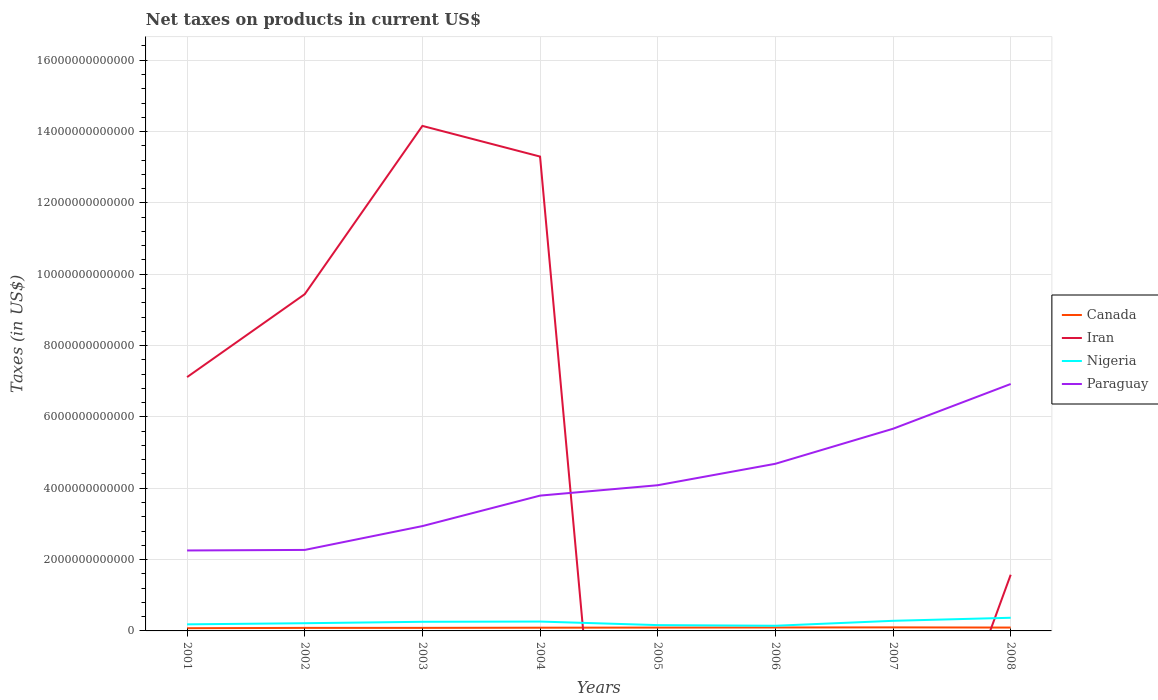How many different coloured lines are there?
Your response must be concise. 4. Is the number of lines equal to the number of legend labels?
Make the answer very short. No. Across all years, what is the maximum net taxes on products in Iran?
Offer a very short reply. 0. What is the total net taxes on products in Paraguay in the graph?
Your answer should be very brief. -6.01e+11. What is the difference between the highest and the second highest net taxes on products in Nigeria?
Provide a succinct answer. 2.24e+11. Is the net taxes on products in Paraguay strictly greater than the net taxes on products in Nigeria over the years?
Your answer should be compact. No. How many years are there in the graph?
Your answer should be compact. 8. What is the difference between two consecutive major ticks on the Y-axis?
Offer a terse response. 2.00e+12. Does the graph contain any zero values?
Provide a short and direct response. Yes. How are the legend labels stacked?
Give a very brief answer. Vertical. What is the title of the graph?
Provide a succinct answer. Net taxes on products in current US$. What is the label or title of the Y-axis?
Ensure brevity in your answer.  Taxes (in US$). What is the Taxes (in US$) in Canada in 2001?
Give a very brief answer. 7.62e+1. What is the Taxes (in US$) in Iran in 2001?
Make the answer very short. 7.12e+12. What is the Taxes (in US$) in Nigeria in 2001?
Give a very brief answer. 1.84e+11. What is the Taxes (in US$) in Paraguay in 2001?
Provide a short and direct response. 2.26e+12. What is the Taxes (in US$) in Canada in 2002?
Keep it short and to the point. 8.48e+1. What is the Taxes (in US$) of Iran in 2002?
Make the answer very short. 9.44e+12. What is the Taxes (in US$) of Nigeria in 2002?
Keep it short and to the point. 2.16e+11. What is the Taxes (in US$) in Paraguay in 2002?
Ensure brevity in your answer.  2.27e+12. What is the Taxes (in US$) in Canada in 2003?
Your answer should be very brief. 8.53e+1. What is the Taxes (in US$) in Iran in 2003?
Your response must be concise. 1.42e+13. What is the Taxes (in US$) of Nigeria in 2003?
Make the answer very short. 2.56e+11. What is the Taxes (in US$) in Paraguay in 2003?
Offer a terse response. 2.94e+12. What is the Taxes (in US$) in Canada in 2004?
Your response must be concise. 9.02e+1. What is the Taxes (in US$) of Iran in 2004?
Provide a succinct answer. 1.33e+13. What is the Taxes (in US$) of Nigeria in 2004?
Provide a succinct answer. 2.63e+11. What is the Taxes (in US$) of Paraguay in 2004?
Offer a terse response. 3.79e+12. What is the Taxes (in US$) in Canada in 2005?
Provide a succinct answer. 9.38e+1. What is the Taxes (in US$) in Nigeria in 2005?
Provide a short and direct response. 1.63e+11. What is the Taxes (in US$) in Paraguay in 2005?
Your answer should be compact. 4.08e+12. What is the Taxes (in US$) of Canada in 2006?
Your response must be concise. 9.66e+1. What is the Taxes (in US$) of Iran in 2006?
Keep it short and to the point. 0. What is the Taxes (in US$) of Nigeria in 2006?
Keep it short and to the point. 1.45e+11. What is the Taxes (in US$) in Paraguay in 2006?
Your response must be concise. 4.69e+12. What is the Taxes (in US$) in Canada in 2007?
Ensure brevity in your answer.  9.92e+1. What is the Taxes (in US$) of Nigeria in 2007?
Your answer should be compact. 2.84e+11. What is the Taxes (in US$) of Paraguay in 2007?
Provide a short and direct response. 5.67e+12. What is the Taxes (in US$) in Canada in 2008?
Provide a short and direct response. 9.43e+1. What is the Taxes (in US$) in Iran in 2008?
Make the answer very short. 1.58e+12. What is the Taxes (in US$) of Nigeria in 2008?
Ensure brevity in your answer.  3.69e+11. What is the Taxes (in US$) of Paraguay in 2008?
Your answer should be very brief. 6.92e+12. Across all years, what is the maximum Taxes (in US$) in Canada?
Your answer should be compact. 9.92e+1. Across all years, what is the maximum Taxes (in US$) of Iran?
Provide a short and direct response. 1.42e+13. Across all years, what is the maximum Taxes (in US$) of Nigeria?
Give a very brief answer. 3.69e+11. Across all years, what is the maximum Taxes (in US$) of Paraguay?
Provide a succinct answer. 6.92e+12. Across all years, what is the minimum Taxes (in US$) in Canada?
Make the answer very short. 7.62e+1. Across all years, what is the minimum Taxes (in US$) in Iran?
Your answer should be very brief. 0. Across all years, what is the minimum Taxes (in US$) in Nigeria?
Provide a succinct answer. 1.45e+11. Across all years, what is the minimum Taxes (in US$) of Paraguay?
Ensure brevity in your answer.  2.26e+12. What is the total Taxes (in US$) in Canada in the graph?
Your answer should be compact. 7.20e+11. What is the total Taxes (in US$) in Iran in the graph?
Offer a terse response. 4.56e+13. What is the total Taxes (in US$) of Nigeria in the graph?
Give a very brief answer. 1.88e+12. What is the total Taxes (in US$) in Paraguay in the graph?
Offer a terse response. 3.26e+13. What is the difference between the Taxes (in US$) of Canada in 2001 and that in 2002?
Your response must be concise. -8.55e+09. What is the difference between the Taxes (in US$) in Iran in 2001 and that in 2002?
Provide a short and direct response. -2.32e+12. What is the difference between the Taxes (in US$) in Nigeria in 2001 and that in 2002?
Ensure brevity in your answer.  -3.14e+1. What is the difference between the Taxes (in US$) in Paraguay in 2001 and that in 2002?
Your answer should be compact. -1.52e+1. What is the difference between the Taxes (in US$) in Canada in 2001 and that in 2003?
Your answer should be compact. -9.03e+09. What is the difference between the Taxes (in US$) of Iran in 2001 and that in 2003?
Make the answer very short. -7.04e+12. What is the difference between the Taxes (in US$) of Nigeria in 2001 and that in 2003?
Your answer should be compact. -7.12e+1. What is the difference between the Taxes (in US$) of Paraguay in 2001 and that in 2003?
Keep it short and to the point. -6.84e+11. What is the difference between the Taxes (in US$) of Canada in 2001 and that in 2004?
Your answer should be very brief. -1.40e+1. What is the difference between the Taxes (in US$) of Iran in 2001 and that in 2004?
Ensure brevity in your answer.  -6.18e+12. What is the difference between the Taxes (in US$) of Nigeria in 2001 and that in 2004?
Your response must be concise. -7.81e+1. What is the difference between the Taxes (in US$) of Paraguay in 2001 and that in 2004?
Give a very brief answer. -1.54e+12. What is the difference between the Taxes (in US$) in Canada in 2001 and that in 2005?
Your response must be concise. -1.75e+1. What is the difference between the Taxes (in US$) of Nigeria in 2001 and that in 2005?
Your answer should be compact. 2.14e+1. What is the difference between the Taxes (in US$) in Paraguay in 2001 and that in 2005?
Provide a short and direct response. -1.83e+12. What is the difference between the Taxes (in US$) of Canada in 2001 and that in 2006?
Offer a very short reply. -2.03e+1. What is the difference between the Taxes (in US$) of Nigeria in 2001 and that in 2006?
Your answer should be compact. 3.95e+1. What is the difference between the Taxes (in US$) of Paraguay in 2001 and that in 2006?
Give a very brief answer. -2.43e+12. What is the difference between the Taxes (in US$) of Canada in 2001 and that in 2007?
Offer a terse response. -2.30e+1. What is the difference between the Taxes (in US$) of Nigeria in 2001 and that in 2007?
Make the answer very short. -9.92e+1. What is the difference between the Taxes (in US$) of Paraguay in 2001 and that in 2007?
Keep it short and to the point. -3.41e+12. What is the difference between the Taxes (in US$) in Canada in 2001 and that in 2008?
Give a very brief answer. -1.80e+1. What is the difference between the Taxes (in US$) of Iran in 2001 and that in 2008?
Your answer should be compact. 5.54e+12. What is the difference between the Taxes (in US$) of Nigeria in 2001 and that in 2008?
Provide a short and direct response. -1.84e+11. What is the difference between the Taxes (in US$) of Paraguay in 2001 and that in 2008?
Your answer should be very brief. -4.67e+12. What is the difference between the Taxes (in US$) of Canada in 2002 and that in 2003?
Provide a short and direct response. -4.84e+08. What is the difference between the Taxes (in US$) of Iran in 2002 and that in 2003?
Your answer should be compact. -4.72e+12. What is the difference between the Taxes (in US$) in Nigeria in 2002 and that in 2003?
Keep it short and to the point. -3.98e+1. What is the difference between the Taxes (in US$) in Paraguay in 2002 and that in 2003?
Ensure brevity in your answer.  -6.68e+11. What is the difference between the Taxes (in US$) of Canada in 2002 and that in 2004?
Provide a succinct answer. -5.42e+09. What is the difference between the Taxes (in US$) in Iran in 2002 and that in 2004?
Make the answer very short. -3.86e+12. What is the difference between the Taxes (in US$) of Nigeria in 2002 and that in 2004?
Give a very brief answer. -4.67e+1. What is the difference between the Taxes (in US$) in Paraguay in 2002 and that in 2004?
Offer a very short reply. -1.52e+12. What is the difference between the Taxes (in US$) of Canada in 2002 and that in 2005?
Provide a succinct answer. -8.98e+09. What is the difference between the Taxes (in US$) of Nigeria in 2002 and that in 2005?
Your answer should be compact. 5.27e+1. What is the difference between the Taxes (in US$) of Paraguay in 2002 and that in 2005?
Your response must be concise. -1.81e+12. What is the difference between the Taxes (in US$) in Canada in 2002 and that in 2006?
Offer a very short reply. -1.18e+1. What is the difference between the Taxes (in US$) of Nigeria in 2002 and that in 2006?
Offer a very short reply. 7.08e+1. What is the difference between the Taxes (in US$) of Paraguay in 2002 and that in 2006?
Offer a terse response. -2.42e+12. What is the difference between the Taxes (in US$) of Canada in 2002 and that in 2007?
Your answer should be very brief. -1.44e+1. What is the difference between the Taxes (in US$) in Nigeria in 2002 and that in 2007?
Your answer should be very brief. -6.78e+1. What is the difference between the Taxes (in US$) of Paraguay in 2002 and that in 2007?
Offer a very short reply. -3.40e+12. What is the difference between the Taxes (in US$) in Canada in 2002 and that in 2008?
Offer a terse response. -9.50e+09. What is the difference between the Taxes (in US$) in Iran in 2002 and that in 2008?
Make the answer very short. 7.87e+12. What is the difference between the Taxes (in US$) in Nigeria in 2002 and that in 2008?
Your answer should be compact. -1.53e+11. What is the difference between the Taxes (in US$) in Paraguay in 2002 and that in 2008?
Your response must be concise. -4.65e+12. What is the difference between the Taxes (in US$) of Canada in 2003 and that in 2004?
Offer a very short reply. -4.94e+09. What is the difference between the Taxes (in US$) of Iran in 2003 and that in 2004?
Your answer should be very brief. 8.60e+11. What is the difference between the Taxes (in US$) of Nigeria in 2003 and that in 2004?
Give a very brief answer. -6.92e+09. What is the difference between the Taxes (in US$) in Paraguay in 2003 and that in 2004?
Provide a succinct answer. -8.55e+11. What is the difference between the Taxes (in US$) of Canada in 2003 and that in 2005?
Make the answer very short. -8.50e+09. What is the difference between the Taxes (in US$) in Nigeria in 2003 and that in 2005?
Ensure brevity in your answer.  9.25e+1. What is the difference between the Taxes (in US$) of Paraguay in 2003 and that in 2005?
Provide a succinct answer. -1.15e+12. What is the difference between the Taxes (in US$) of Canada in 2003 and that in 2006?
Provide a short and direct response. -1.13e+1. What is the difference between the Taxes (in US$) of Nigeria in 2003 and that in 2006?
Your answer should be very brief. 1.11e+11. What is the difference between the Taxes (in US$) of Paraguay in 2003 and that in 2006?
Offer a very short reply. -1.75e+12. What is the difference between the Taxes (in US$) in Canada in 2003 and that in 2007?
Offer a terse response. -1.39e+1. What is the difference between the Taxes (in US$) of Nigeria in 2003 and that in 2007?
Provide a succinct answer. -2.80e+1. What is the difference between the Taxes (in US$) of Paraguay in 2003 and that in 2007?
Ensure brevity in your answer.  -2.73e+12. What is the difference between the Taxes (in US$) in Canada in 2003 and that in 2008?
Provide a succinct answer. -9.01e+09. What is the difference between the Taxes (in US$) of Iran in 2003 and that in 2008?
Your answer should be compact. 1.26e+13. What is the difference between the Taxes (in US$) of Nigeria in 2003 and that in 2008?
Give a very brief answer. -1.13e+11. What is the difference between the Taxes (in US$) of Paraguay in 2003 and that in 2008?
Give a very brief answer. -3.98e+12. What is the difference between the Taxes (in US$) of Canada in 2004 and that in 2005?
Your answer should be compact. -3.56e+09. What is the difference between the Taxes (in US$) in Nigeria in 2004 and that in 2005?
Your response must be concise. 9.95e+1. What is the difference between the Taxes (in US$) of Paraguay in 2004 and that in 2005?
Your answer should be very brief. -2.91e+11. What is the difference between the Taxes (in US$) of Canada in 2004 and that in 2006?
Offer a very short reply. -6.34e+09. What is the difference between the Taxes (in US$) of Nigeria in 2004 and that in 2006?
Your response must be concise. 1.18e+11. What is the difference between the Taxes (in US$) of Paraguay in 2004 and that in 2006?
Keep it short and to the point. -8.92e+11. What is the difference between the Taxes (in US$) of Canada in 2004 and that in 2007?
Keep it short and to the point. -8.99e+09. What is the difference between the Taxes (in US$) in Nigeria in 2004 and that in 2007?
Provide a short and direct response. -2.11e+1. What is the difference between the Taxes (in US$) of Paraguay in 2004 and that in 2007?
Offer a terse response. -1.87e+12. What is the difference between the Taxes (in US$) in Canada in 2004 and that in 2008?
Make the answer very short. -4.08e+09. What is the difference between the Taxes (in US$) of Iran in 2004 and that in 2008?
Keep it short and to the point. 1.17e+13. What is the difference between the Taxes (in US$) of Nigeria in 2004 and that in 2008?
Offer a terse response. -1.06e+11. What is the difference between the Taxes (in US$) of Paraguay in 2004 and that in 2008?
Give a very brief answer. -3.13e+12. What is the difference between the Taxes (in US$) of Canada in 2005 and that in 2006?
Keep it short and to the point. -2.78e+09. What is the difference between the Taxes (in US$) in Nigeria in 2005 and that in 2006?
Offer a terse response. 1.81e+1. What is the difference between the Taxes (in US$) in Paraguay in 2005 and that in 2006?
Provide a succinct answer. -6.01e+11. What is the difference between the Taxes (in US$) of Canada in 2005 and that in 2007?
Give a very brief answer. -5.43e+09. What is the difference between the Taxes (in US$) in Nigeria in 2005 and that in 2007?
Provide a short and direct response. -1.21e+11. What is the difference between the Taxes (in US$) of Paraguay in 2005 and that in 2007?
Make the answer very short. -1.58e+12. What is the difference between the Taxes (in US$) of Canada in 2005 and that in 2008?
Provide a succinct answer. -5.15e+08. What is the difference between the Taxes (in US$) in Nigeria in 2005 and that in 2008?
Make the answer very short. -2.06e+11. What is the difference between the Taxes (in US$) in Paraguay in 2005 and that in 2008?
Make the answer very short. -2.84e+12. What is the difference between the Taxes (in US$) of Canada in 2006 and that in 2007?
Give a very brief answer. -2.65e+09. What is the difference between the Taxes (in US$) of Nigeria in 2006 and that in 2007?
Provide a short and direct response. -1.39e+11. What is the difference between the Taxes (in US$) in Paraguay in 2006 and that in 2007?
Your response must be concise. -9.82e+11. What is the difference between the Taxes (in US$) in Canada in 2006 and that in 2008?
Provide a short and direct response. 2.27e+09. What is the difference between the Taxes (in US$) in Nigeria in 2006 and that in 2008?
Your answer should be compact. -2.24e+11. What is the difference between the Taxes (in US$) of Paraguay in 2006 and that in 2008?
Make the answer very short. -2.24e+12. What is the difference between the Taxes (in US$) of Canada in 2007 and that in 2008?
Ensure brevity in your answer.  4.92e+09. What is the difference between the Taxes (in US$) of Nigeria in 2007 and that in 2008?
Keep it short and to the point. -8.53e+1. What is the difference between the Taxes (in US$) in Paraguay in 2007 and that in 2008?
Offer a very short reply. -1.25e+12. What is the difference between the Taxes (in US$) in Canada in 2001 and the Taxes (in US$) in Iran in 2002?
Provide a short and direct response. -9.36e+12. What is the difference between the Taxes (in US$) in Canada in 2001 and the Taxes (in US$) in Nigeria in 2002?
Provide a succinct answer. -1.40e+11. What is the difference between the Taxes (in US$) in Canada in 2001 and the Taxes (in US$) in Paraguay in 2002?
Your answer should be very brief. -2.19e+12. What is the difference between the Taxes (in US$) in Iran in 2001 and the Taxes (in US$) in Nigeria in 2002?
Provide a short and direct response. 6.90e+12. What is the difference between the Taxes (in US$) in Iran in 2001 and the Taxes (in US$) in Paraguay in 2002?
Make the answer very short. 4.85e+12. What is the difference between the Taxes (in US$) in Nigeria in 2001 and the Taxes (in US$) in Paraguay in 2002?
Provide a short and direct response. -2.09e+12. What is the difference between the Taxes (in US$) of Canada in 2001 and the Taxes (in US$) of Iran in 2003?
Your response must be concise. -1.41e+13. What is the difference between the Taxes (in US$) in Canada in 2001 and the Taxes (in US$) in Nigeria in 2003?
Offer a very short reply. -1.79e+11. What is the difference between the Taxes (in US$) of Canada in 2001 and the Taxes (in US$) of Paraguay in 2003?
Ensure brevity in your answer.  -2.86e+12. What is the difference between the Taxes (in US$) in Iran in 2001 and the Taxes (in US$) in Nigeria in 2003?
Ensure brevity in your answer.  6.86e+12. What is the difference between the Taxes (in US$) of Iran in 2001 and the Taxes (in US$) of Paraguay in 2003?
Your response must be concise. 4.18e+12. What is the difference between the Taxes (in US$) in Nigeria in 2001 and the Taxes (in US$) in Paraguay in 2003?
Offer a terse response. -2.75e+12. What is the difference between the Taxes (in US$) in Canada in 2001 and the Taxes (in US$) in Iran in 2004?
Offer a terse response. -1.32e+13. What is the difference between the Taxes (in US$) in Canada in 2001 and the Taxes (in US$) in Nigeria in 2004?
Your response must be concise. -1.86e+11. What is the difference between the Taxes (in US$) in Canada in 2001 and the Taxes (in US$) in Paraguay in 2004?
Give a very brief answer. -3.72e+12. What is the difference between the Taxes (in US$) of Iran in 2001 and the Taxes (in US$) of Nigeria in 2004?
Make the answer very short. 6.85e+12. What is the difference between the Taxes (in US$) of Iran in 2001 and the Taxes (in US$) of Paraguay in 2004?
Keep it short and to the point. 3.32e+12. What is the difference between the Taxes (in US$) in Nigeria in 2001 and the Taxes (in US$) in Paraguay in 2004?
Make the answer very short. -3.61e+12. What is the difference between the Taxes (in US$) in Canada in 2001 and the Taxes (in US$) in Nigeria in 2005?
Keep it short and to the point. -8.68e+1. What is the difference between the Taxes (in US$) in Canada in 2001 and the Taxes (in US$) in Paraguay in 2005?
Provide a succinct answer. -4.01e+12. What is the difference between the Taxes (in US$) of Iran in 2001 and the Taxes (in US$) of Nigeria in 2005?
Give a very brief answer. 6.95e+12. What is the difference between the Taxes (in US$) in Iran in 2001 and the Taxes (in US$) in Paraguay in 2005?
Keep it short and to the point. 3.03e+12. What is the difference between the Taxes (in US$) of Nigeria in 2001 and the Taxes (in US$) of Paraguay in 2005?
Your answer should be compact. -3.90e+12. What is the difference between the Taxes (in US$) of Canada in 2001 and the Taxes (in US$) of Nigeria in 2006?
Your answer should be very brief. -6.87e+1. What is the difference between the Taxes (in US$) of Canada in 2001 and the Taxes (in US$) of Paraguay in 2006?
Keep it short and to the point. -4.61e+12. What is the difference between the Taxes (in US$) of Iran in 2001 and the Taxes (in US$) of Nigeria in 2006?
Your response must be concise. 6.97e+12. What is the difference between the Taxes (in US$) of Iran in 2001 and the Taxes (in US$) of Paraguay in 2006?
Offer a terse response. 2.43e+12. What is the difference between the Taxes (in US$) of Nigeria in 2001 and the Taxes (in US$) of Paraguay in 2006?
Your answer should be very brief. -4.50e+12. What is the difference between the Taxes (in US$) of Canada in 2001 and the Taxes (in US$) of Nigeria in 2007?
Your response must be concise. -2.07e+11. What is the difference between the Taxes (in US$) of Canada in 2001 and the Taxes (in US$) of Paraguay in 2007?
Offer a terse response. -5.59e+12. What is the difference between the Taxes (in US$) in Iran in 2001 and the Taxes (in US$) in Nigeria in 2007?
Make the answer very short. 6.83e+12. What is the difference between the Taxes (in US$) of Iran in 2001 and the Taxes (in US$) of Paraguay in 2007?
Give a very brief answer. 1.45e+12. What is the difference between the Taxes (in US$) of Nigeria in 2001 and the Taxes (in US$) of Paraguay in 2007?
Your response must be concise. -5.48e+12. What is the difference between the Taxes (in US$) in Canada in 2001 and the Taxes (in US$) in Iran in 2008?
Your answer should be very brief. -1.50e+12. What is the difference between the Taxes (in US$) of Canada in 2001 and the Taxes (in US$) of Nigeria in 2008?
Ensure brevity in your answer.  -2.93e+11. What is the difference between the Taxes (in US$) of Canada in 2001 and the Taxes (in US$) of Paraguay in 2008?
Offer a very short reply. -6.85e+12. What is the difference between the Taxes (in US$) in Iran in 2001 and the Taxes (in US$) in Nigeria in 2008?
Provide a short and direct response. 6.75e+12. What is the difference between the Taxes (in US$) of Iran in 2001 and the Taxes (in US$) of Paraguay in 2008?
Your answer should be compact. 1.93e+11. What is the difference between the Taxes (in US$) in Nigeria in 2001 and the Taxes (in US$) in Paraguay in 2008?
Give a very brief answer. -6.74e+12. What is the difference between the Taxes (in US$) in Canada in 2002 and the Taxes (in US$) in Iran in 2003?
Ensure brevity in your answer.  -1.41e+13. What is the difference between the Taxes (in US$) of Canada in 2002 and the Taxes (in US$) of Nigeria in 2003?
Your response must be concise. -1.71e+11. What is the difference between the Taxes (in US$) of Canada in 2002 and the Taxes (in US$) of Paraguay in 2003?
Give a very brief answer. -2.85e+12. What is the difference between the Taxes (in US$) of Iran in 2002 and the Taxes (in US$) of Nigeria in 2003?
Keep it short and to the point. 9.19e+12. What is the difference between the Taxes (in US$) of Iran in 2002 and the Taxes (in US$) of Paraguay in 2003?
Offer a very short reply. 6.50e+12. What is the difference between the Taxes (in US$) in Nigeria in 2002 and the Taxes (in US$) in Paraguay in 2003?
Your answer should be compact. -2.72e+12. What is the difference between the Taxes (in US$) in Canada in 2002 and the Taxes (in US$) in Iran in 2004?
Give a very brief answer. -1.32e+13. What is the difference between the Taxes (in US$) of Canada in 2002 and the Taxes (in US$) of Nigeria in 2004?
Offer a very short reply. -1.78e+11. What is the difference between the Taxes (in US$) of Canada in 2002 and the Taxes (in US$) of Paraguay in 2004?
Provide a succinct answer. -3.71e+12. What is the difference between the Taxes (in US$) of Iran in 2002 and the Taxes (in US$) of Nigeria in 2004?
Keep it short and to the point. 9.18e+12. What is the difference between the Taxes (in US$) in Iran in 2002 and the Taxes (in US$) in Paraguay in 2004?
Give a very brief answer. 5.65e+12. What is the difference between the Taxes (in US$) in Nigeria in 2002 and the Taxes (in US$) in Paraguay in 2004?
Make the answer very short. -3.58e+12. What is the difference between the Taxes (in US$) of Canada in 2002 and the Taxes (in US$) of Nigeria in 2005?
Offer a terse response. -7.83e+1. What is the difference between the Taxes (in US$) of Canada in 2002 and the Taxes (in US$) of Paraguay in 2005?
Make the answer very short. -4.00e+12. What is the difference between the Taxes (in US$) of Iran in 2002 and the Taxes (in US$) of Nigeria in 2005?
Give a very brief answer. 9.28e+12. What is the difference between the Taxes (in US$) in Iran in 2002 and the Taxes (in US$) in Paraguay in 2005?
Your answer should be compact. 5.36e+12. What is the difference between the Taxes (in US$) of Nigeria in 2002 and the Taxes (in US$) of Paraguay in 2005?
Your response must be concise. -3.87e+12. What is the difference between the Taxes (in US$) in Canada in 2002 and the Taxes (in US$) in Nigeria in 2006?
Keep it short and to the point. -6.02e+1. What is the difference between the Taxes (in US$) of Canada in 2002 and the Taxes (in US$) of Paraguay in 2006?
Offer a terse response. -4.60e+12. What is the difference between the Taxes (in US$) in Iran in 2002 and the Taxes (in US$) in Nigeria in 2006?
Give a very brief answer. 9.30e+12. What is the difference between the Taxes (in US$) in Iran in 2002 and the Taxes (in US$) in Paraguay in 2006?
Give a very brief answer. 4.76e+12. What is the difference between the Taxes (in US$) of Nigeria in 2002 and the Taxes (in US$) of Paraguay in 2006?
Your answer should be compact. -4.47e+12. What is the difference between the Taxes (in US$) of Canada in 2002 and the Taxes (in US$) of Nigeria in 2007?
Give a very brief answer. -1.99e+11. What is the difference between the Taxes (in US$) in Canada in 2002 and the Taxes (in US$) in Paraguay in 2007?
Provide a succinct answer. -5.58e+12. What is the difference between the Taxes (in US$) of Iran in 2002 and the Taxes (in US$) of Nigeria in 2007?
Provide a short and direct response. 9.16e+12. What is the difference between the Taxes (in US$) in Iran in 2002 and the Taxes (in US$) in Paraguay in 2007?
Offer a very short reply. 3.77e+12. What is the difference between the Taxes (in US$) of Nigeria in 2002 and the Taxes (in US$) of Paraguay in 2007?
Provide a short and direct response. -5.45e+12. What is the difference between the Taxes (in US$) of Canada in 2002 and the Taxes (in US$) of Iran in 2008?
Provide a succinct answer. -1.49e+12. What is the difference between the Taxes (in US$) in Canada in 2002 and the Taxes (in US$) in Nigeria in 2008?
Give a very brief answer. -2.84e+11. What is the difference between the Taxes (in US$) in Canada in 2002 and the Taxes (in US$) in Paraguay in 2008?
Your answer should be compact. -6.84e+12. What is the difference between the Taxes (in US$) of Iran in 2002 and the Taxes (in US$) of Nigeria in 2008?
Your answer should be very brief. 9.07e+12. What is the difference between the Taxes (in US$) of Iran in 2002 and the Taxes (in US$) of Paraguay in 2008?
Offer a very short reply. 2.52e+12. What is the difference between the Taxes (in US$) in Nigeria in 2002 and the Taxes (in US$) in Paraguay in 2008?
Your answer should be compact. -6.71e+12. What is the difference between the Taxes (in US$) of Canada in 2003 and the Taxes (in US$) of Iran in 2004?
Your answer should be compact. -1.32e+13. What is the difference between the Taxes (in US$) in Canada in 2003 and the Taxes (in US$) in Nigeria in 2004?
Give a very brief answer. -1.77e+11. What is the difference between the Taxes (in US$) of Canada in 2003 and the Taxes (in US$) of Paraguay in 2004?
Ensure brevity in your answer.  -3.71e+12. What is the difference between the Taxes (in US$) of Iran in 2003 and the Taxes (in US$) of Nigeria in 2004?
Your response must be concise. 1.39e+13. What is the difference between the Taxes (in US$) in Iran in 2003 and the Taxes (in US$) in Paraguay in 2004?
Ensure brevity in your answer.  1.04e+13. What is the difference between the Taxes (in US$) of Nigeria in 2003 and the Taxes (in US$) of Paraguay in 2004?
Make the answer very short. -3.54e+12. What is the difference between the Taxes (in US$) of Canada in 2003 and the Taxes (in US$) of Nigeria in 2005?
Your response must be concise. -7.78e+1. What is the difference between the Taxes (in US$) in Canada in 2003 and the Taxes (in US$) in Paraguay in 2005?
Ensure brevity in your answer.  -4.00e+12. What is the difference between the Taxes (in US$) of Iran in 2003 and the Taxes (in US$) of Nigeria in 2005?
Offer a terse response. 1.40e+13. What is the difference between the Taxes (in US$) in Iran in 2003 and the Taxes (in US$) in Paraguay in 2005?
Your response must be concise. 1.01e+13. What is the difference between the Taxes (in US$) of Nigeria in 2003 and the Taxes (in US$) of Paraguay in 2005?
Your answer should be very brief. -3.83e+12. What is the difference between the Taxes (in US$) in Canada in 2003 and the Taxes (in US$) in Nigeria in 2006?
Give a very brief answer. -5.97e+1. What is the difference between the Taxes (in US$) of Canada in 2003 and the Taxes (in US$) of Paraguay in 2006?
Your answer should be compact. -4.60e+12. What is the difference between the Taxes (in US$) of Iran in 2003 and the Taxes (in US$) of Nigeria in 2006?
Make the answer very short. 1.40e+13. What is the difference between the Taxes (in US$) in Iran in 2003 and the Taxes (in US$) in Paraguay in 2006?
Ensure brevity in your answer.  9.47e+12. What is the difference between the Taxes (in US$) of Nigeria in 2003 and the Taxes (in US$) of Paraguay in 2006?
Keep it short and to the point. -4.43e+12. What is the difference between the Taxes (in US$) of Canada in 2003 and the Taxes (in US$) of Nigeria in 2007?
Provide a short and direct response. -1.98e+11. What is the difference between the Taxes (in US$) in Canada in 2003 and the Taxes (in US$) in Paraguay in 2007?
Keep it short and to the point. -5.58e+12. What is the difference between the Taxes (in US$) of Iran in 2003 and the Taxes (in US$) of Nigeria in 2007?
Ensure brevity in your answer.  1.39e+13. What is the difference between the Taxes (in US$) of Iran in 2003 and the Taxes (in US$) of Paraguay in 2007?
Your answer should be very brief. 8.49e+12. What is the difference between the Taxes (in US$) of Nigeria in 2003 and the Taxes (in US$) of Paraguay in 2007?
Keep it short and to the point. -5.41e+12. What is the difference between the Taxes (in US$) in Canada in 2003 and the Taxes (in US$) in Iran in 2008?
Your answer should be compact. -1.49e+12. What is the difference between the Taxes (in US$) in Canada in 2003 and the Taxes (in US$) in Nigeria in 2008?
Offer a very short reply. -2.84e+11. What is the difference between the Taxes (in US$) in Canada in 2003 and the Taxes (in US$) in Paraguay in 2008?
Offer a very short reply. -6.84e+12. What is the difference between the Taxes (in US$) in Iran in 2003 and the Taxes (in US$) in Nigeria in 2008?
Give a very brief answer. 1.38e+13. What is the difference between the Taxes (in US$) of Iran in 2003 and the Taxes (in US$) of Paraguay in 2008?
Provide a short and direct response. 7.24e+12. What is the difference between the Taxes (in US$) of Nigeria in 2003 and the Taxes (in US$) of Paraguay in 2008?
Your response must be concise. -6.67e+12. What is the difference between the Taxes (in US$) of Canada in 2004 and the Taxes (in US$) of Nigeria in 2005?
Your response must be concise. -7.29e+1. What is the difference between the Taxes (in US$) in Canada in 2004 and the Taxes (in US$) in Paraguay in 2005?
Make the answer very short. -3.99e+12. What is the difference between the Taxes (in US$) in Iran in 2004 and the Taxes (in US$) in Nigeria in 2005?
Provide a succinct answer. 1.31e+13. What is the difference between the Taxes (in US$) in Iran in 2004 and the Taxes (in US$) in Paraguay in 2005?
Make the answer very short. 9.21e+12. What is the difference between the Taxes (in US$) of Nigeria in 2004 and the Taxes (in US$) of Paraguay in 2005?
Keep it short and to the point. -3.82e+12. What is the difference between the Taxes (in US$) of Canada in 2004 and the Taxes (in US$) of Nigeria in 2006?
Ensure brevity in your answer.  -5.48e+1. What is the difference between the Taxes (in US$) of Canada in 2004 and the Taxes (in US$) of Paraguay in 2006?
Provide a short and direct response. -4.60e+12. What is the difference between the Taxes (in US$) in Iran in 2004 and the Taxes (in US$) in Nigeria in 2006?
Provide a succinct answer. 1.32e+13. What is the difference between the Taxes (in US$) in Iran in 2004 and the Taxes (in US$) in Paraguay in 2006?
Make the answer very short. 8.61e+12. What is the difference between the Taxes (in US$) in Nigeria in 2004 and the Taxes (in US$) in Paraguay in 2006?
Give a very brief answer. -4.42e+12. What is the difference between the Taxes (in US$) of Canada in 2004 and the Taxes (in US$) of Nigeria in 2007?
Provide a short and direct response. -1.93e+11. What is the difference between the Taxes (in US$) in Canada in 2004 and the Taxes (in US$) in Paraguay in 2007?
Keep it short and to the point. -5.58e+12. What is the difference between the Taxes (in US$) of Iran in 2004 and the Taxes (in US$) of Nigeria in 2007?
Offer a terse response. 1.30e+13. What is the difference between the Taxes (in US$) of Iran in 2004 and the Taxes (in US$) of Paraguay in 2007?
Provide a short and direct response. 7.63e+12. What is the difference between the Taxes (in US$) of Nigeria in 2004 and the Taxes (in US$) of Paraguay in 2007?
Your response must be concise. -5.41e+12. What is the difference between the Taxes (in US$) of Canada in 2004 and the Taxes (in US$) of Iran in 2008?
Your answer should be very brief. -1.49e+12. What is the difference between the Taxes (in US$) in Canada in 2004 and the Taxes (in US$) in Nigeria in 2008?
Keep it short and to the point. -2.79e+11. What is the difference between the Taxes (in US$) of Canada in 2004 and the Taxes (in US$) of Paraguay in 2008?
Provide a succinct answer. -6.83e+12. What is the difference between the Taxes (in US$) in Iran in 2004 and the Taxes (in US$) in Nigeria in 2008?
Provide a short and direct response. 1.29e+13. What is the difference between the Taxes (in US$) of Iran in 2004 and the Taxes (in US$) of Paraguay in 2008?
Offer a very short reply. 6.38e+12. What is the difference between the Taxes (in US$) in Nigeria in 2004 and the Taxes (in US$) in Paraguay in 2008?
Make the answer very short. -6.66e+12. What is the difference between the Taxes (in US$) of Canada in 2005 and the Taxes (in US$) of Nigeria in 2006?
Keep it short and to the point. -5.12e+1. What is the difference between the Taxes (in US$) of Canada in 2005 and the Taxes (in US$) of Paraguay in 2006?
Make the answer very short. -4.59e+12. What is the difference between the Taxes (in US$) of Nigeria in 2005 and the Taxes (in US$) of Paraguay in 2006?
Provide a succinct answer. -4.52e+12. What is the difference between the Taxes (in US$) of Canada in 2005 and the Taxes (in US$) of Nigeria in 2007?
Offer a terse response. -1.90e+11. What is the difference between the Taxes (in US$) in Canada in 2005 and the Taxes (in US$) in Paraguay in 2007?
Offer a very short reply. -5.57e+12. What is the difference between the Taxes (in US$) in Nigeria in 2005 and the Taxes (in US$) in Paraguay in 2007?
Make the answer very short. -5.51e+12. What is the difference between the Taxes (in US$) of Canada in 2005 and the Taxes (in US$) of Iran in 2008?
Your response must be concise. -1.48e+12. What is the difference between the Taxes (in US$) of Canada in 2005 and the Taxes (in US$) of Nigeria in 2008?
Your response must be concise. -2.75e+11. What is the difference between the Taxes (in US$) in Canada in 2005 and the Taxes (in US$) in Paraguay in 2008?
Provide a short and direct response. -6.83e+12. What is the difference between the Taxes (in US$) of Nigeria in 2005 and the Taxes (in US$) of Paraguay in 2008?
Ensure brevity in your answer.  -6.76e+12. What is the difference between the Taxes (in US$) of Canada in 2006 and the Taxes (in US$) of Nigeria in 2007?
Ensure brevity in your answer.  -1.87e+11. What is the difference between the Taxes (in US$) in Canada in 2006 and the Taxes (in US$) in Paraguay in 2007?
Your answer should be very brief. -5.57e+12. What is the difference between the Taxes (in US$) in Nigeria in 2006 and the Taxes (in US$) in Paraguay in 2007?
Keep it short and to the point. -5.52e+12. What is the difference between the Taxes (in US$) of Canada in 2006 and the Taxes (in US$) of Iran in 2008?
Give a very brief answer. -1.48e+12. What is the difference between the Taxes (in US$) of Canada in 2006 and the Taxes (in US$) of Nigeria in 2008?
Ensure brevity in your answer.  -2.72e+11. What is the difference between the Taxes (in US$) of Canada in 2006 and the Taxes (in US$) of Paraguay in 2008?
Provide a succinct answer. -6.83e+12. What is the difference between the Taxes (in US$) of Nigeria in 2006 and the Taxes (in US$) of Paraguay in 2008?
Give a very brief answer. -6.78e+12. What is the difference between the Taxes (in US$) in Canada in 2007 and the Taxes (in US$) in Iran in 2008?
Your answer should be very brief. -1.48e+12. What is the difference between the Taxes (in US$) of Canada in 2007 and the Taxes (in US$) of Nigeria in 2008?
Provide a short and direct response. -2.70e+11. What is the difference between the Taxes (in US$) of Canada in 2007 and the Taxes (in US$) of Paraguay in 2008?
Your response must be concise. -6.82e+12. What is the difference between the Taxes (in US$) in Nigeria in 2007 and the Taxes (in US$) in Paraguay in 2008?
Provide a short and direct response. -6.64e+12. What is the average Taxes (in US$) of Canada per year?
Provide a short and direct response. 9.00e+1. What is the average Taxes (in US$) of Iran per year?
Keep it short and to the point. 5.70e+12. What is the average Taxes (in US$) in Nigeria per year?
Your answer should be compact. 2.35e+11. What is the average Taxes (in US$) in Paraguay per year?
Your response must be concise. 4.08e+12. In the year 2001, what is the difference between the Taxes (in US$) in Canada and Taxes (in US$) in Iran?
Offer a terse response. -7.04e+12. In the year 2001, what is the difference between the Taxes (in US$) in Canada and Taxes (in US$) in Nigeria?
Your answer should be very brief. -1.08e+11. In the year 2001, what is the difference between the Taxes (in US$) in Canada and Taxes (in US$) in Paraguay?
Offer a terse response. -2.18e+12. In the year 2001, what is the difference between the Taxes (in US$) in Iran and Taxes (in US$) in Nigeria?
Your response must be concise. 6.93e+12. In the year 2001, what is the difference between the Taxes (in US$) of Iran and Taxes (in US$) of Paraguay?
Provide a short and direct response. 4.86e+12. In the year 2001, what is the difference between the Taxes (in US$) in Nigeria and Taxes (in US$) in Paraguay?
Your answer should be very brief. -2.07e+12. In the year 2002, what is the difference between the Taxes (in US$) of Canada and Taxes (in US$) of Iran?
Offer a terse response. -9.36e+12. In the year 2002, what is the difference between the Taxes (in US$) of Canada and Taxes (in US$) of Nigeria?
Keep it short and to the point. -1.31e+11. In the year 2002, what is the difference between the Taxes (in US$) of Canada and Taxes (in US$) of Paraguay?
Make the answer very short. -2.19e+12. In the year 2002, what is the difference between the Taxes (in US$) of Iran and Taxes (in US$) of Nigeria?
Your response must be concise. 9.23e+12. In the year 2002, what is the difference between the Taxes (in US$) of Iran and Taxes (in US$) of Paraguay?
Offer a terse response. 7.17e+12. In the year 2002, what is the difference between the Taxes (in US$) of Nigeria and Taxes (in US$) of Paraguay?
Offer a terse response. -2.06e+12. In the year 2003, what is the difference between the Taxes (in US$) of Canada and Taxes (in US$) of Iran?
Give a very brief answer. -1.41e+13. In the year 2003, what is the difference between the Taxes (in US$) of Canada and Taxes (in US$) of Nigeria?
Make the answer very short. -1.70e+11. In the year 2003, what is the difference between the Taxes (in US$) of Canada and Taxes (in US$) of Paraguay?
Your response must be concise. -2.85e+12. In the year 2003, what is the difference between the Taxes (in US$) of Iran and Taxes (in US$) of Nigeria?
Keep it short and to the point. 1.39e+13. In the year 2003, what is the difference between the Taxes (in US$) of Iran and Taxes (in US$) of Paraguay?
Your answer should be compact. 1.12e+13. In the year 2003, what is the difference between the Taxes (in US$) in Nigeria and Taxes (in US$) in Paraguay?
Ensure brevity in your answer.  -2.68e+12. In the year 2004, what is the difference between the Taxes (in US$) in Canada and Taxes (in US$) in Iran?
Provide a succinct answer. -1.32e+13. In the year 2004, what is the difference between the Taxes (in US$) in Canada and Taxes (in US$) in Nigeria?
Provide a short and direct response. -1.72e+11. In the year 2004, what is the difference between the Taxes (in US$) in Canada and Taxes (in US$) in Paraguay?
Ensure brevity in your answer.  -3.70e+12. In the year 2004, what is the difference between the Taxes (in US$) in Iran and Taxes (in US$) in Nigeria?
Give a very brief answer. 1.30e+13. In the year 2004, what is the difference between the Taxes (in US$) of Iran and Taxes (in US$) of Paraguay?
Give a very brief answer. 9.51e+12. In the year 2004, what is the difference between the Taxes (in US$) of Nigeria and Taxes (in US$) of Paraguay?
Keep it short and to the point. -3.53e+12. In the year 2005, what is the difference between the Taxes (in US$) of Canada and Taxes (in US$) of Nigeria?
Offer a terse response. -6.93e+1. In the year 2005, what is the difference between the Taxes (in US$) in Canada and Taxes (in US$) in Paraguay?
Your answer should be very brief. -3.99e+12. In the year 2005, what is the difference between the Taxes (in US$) in Nigeria and Taxes (in US$) in Paraguay?
Your response must be concise. -3.92e+12. In the year 2006, what is the difference between the Taxes (in US$) in Canada and Taxes (in US$) in Nigeria?
Provide a short and direct response. -4.84e+1. In the year 2006, what is the difference between the Taxes (in US$) in Canada and Taxes (in US$) in Paraguay?
Your response must be concise. -4.59e+12. In the year 2006, what is the difference between the Taxes (in US$) of Nigeria and Taxes (in US$) of Paraguay?
Your answer should be very brief. -4.54e+12. In the year 2007, what is the difference between the Taxes (in US$) of Canada and Taxes (in US$) of Nigeria?
Make the answer very short. -1.84e+11. In the year 2007, what is the difference between the Taxes (in US$) in Canada and Taxes (in US$) in Paraguay?
Your response must be concise. -5.57e+12. In the year 2007, what is the difference between the Taxes (in US$) of Nigeria and Taxes (in US$) of Paraguay?
Your answer should be compact. -5.38e+12. In the year 2008, what is the difference between the Taxes (in US$) in Canada and Taxes (in US$) in Iran?
Offer a terse response. -1.48e+12. In the year 2008, what is the difference between the Taxes (in US$) in Canada and Taxes (in US$) in Nigeria?
Offer a terse response. -2.75e+11. In the year 2008, what is the difference between the Taxes (in US$) of Canada and Taxes (in US$) of Paraguay?
Your answer should be very brief. -6.83e+12. In the year 2008, what is the difference between the Taxes (in US$) of Iran and Taxes (in US$) of Nigeria?
Your answer should be very brief. 1.21e+12. In the year 2008, what is the difference between the Taxes (in US$) in Iran and Taxes (in US$) in Paraguay?
Make the answer very short. -5.35e+12. In the year 2008, what is the difference between the Taxes (in US$) of Nigeria and Taxes (in US$) of Paraguay?
Keep it short and to the point. -6.55e+12. What is the ratio of the Taxes (in US$) in Canada in 2001 to that in 2002?
Keep it short and to the point. 0.9. What is the ratio of the Taxes (in US$) of Iran in 2001 to that in 2002?
Provide a short and direct response. 0.75. What is the ratio of the Taxes (in US$) in Nigeria in 2001 to that in 2002?
Your answer should be compact. 0.85. What is the ratio of the Taxes (in US$) in Paraguay in 2001 to that in 2002?
Provide a succinct answer. 0.99. What is the ratio of the Taxes (in US$) in Canada in 2001 to that in 2003?
Your response must be concise. 0.89. What is the ratio of the Taxes (in US$) in Iran in 2001 to that in 2003?
Offer a very short reply. 0.5. What is the ratio of the Taxes (in US$) in Nigeria in 2001 to that in 2003?
Give a very brief answer. 0.72. What is the ratio of the Taxes (in US$) in Paraguay in 2001 to that in 2003?
Your answer should be very brief. 0.77. What is the ratio of the Taxes (in US$) of Canada in 2001 to that in 2004?
Make the answer very short. 0.85. What is the ratio of the Taxes (in US$) of Iran in 2001 to that in 2004?
Ensure brevity in your answer.  0.54. What is the ratio of the Taxes (in US$) of Nigeria in 2001 to that in 2004?
Make the answer very short. 0.7. What is the ratio of the Taxes (in US$) of Paraguay in 2001 to that in 2004?
Your answer should be compact. 0.59. What is the ratio of the Taxes (in US$) in Canada in 2001 to that in 2005?
Your response must be concise. 0.81. What is the ratio of the Taxes (in US$) of Nigeria in 2001 to that in 2005?
Your answer should be compact. 1.13. What is the ratio of the Taxes (in US$) of Paraguay in 2001 to that in 2005?
Provide a succinct answer. 0.55. What is the ratio of the Taxes (in US$) in Canada in 2001 to that in 2006?
Ensure brevity in your answer.  0.79. What is the ratio of the Taxes (in US$) of Nigeria in 2001 to that in 2006?
Give a very brief answer. 1.27. What is the ratio of the Taxes (in US$) in Paraguay in 2001 to that in 2006?
Provide a succinct answer. 0.48. What is the ratio of the Taxes (in US$) in Canada in 2001 to that in 2007?
Provide a succinct answer. 0.77. What is the ratio of the Taxes (in US$) of Nigeria in 2001 to that in 2007?
Your response must be concise. 0.65. What is the ratio of the Taxes (in US$) in Paraguay in 2001 to that in 2007?
Offer a very short reply. 0.4. What is the ratio of the Taxes (in US$) of Canada in 2001 to that in 2008?
Provide a succinct answer. 0.81. What is the ratio of the Taxes (in US$) in Iran in 2001 to that in 2008?
Provide a short and direct response. 4.52. What is the ratio of the Taxes (in US$) of Paraguay in 2001 to that in 2008?
Your response must be concise. 0.33. What is the ratio of the Taxes (in US$) of Iran in 2002 to that in 2003?
Your answer should be very brief. 0.67. What is the ratio of the Taxes (in US$) in Nigeria in 2002 to that in 2003?
Offer a very short reply. 0.84. What is the ratio of the Taxes (in US$) in Paraguay in 2002 to that in 2003?
Keep it short and to the point. 0.77. What is the ratio of the Taxes (in US$) of Canada in 2002 to that in 2004?
Ensure brevity in your answer.  0.94. What is the ratio of the Taxes (in US$) in Iran in 2002 to that in 2004?
Make the answer very short. 0.71. What is the ratio of the Taxes (in US$) of Nigeria in 2002 to that in 2004?
Provide a short and direct response. 0.82. What is the ratio of the Taxes (in US$) in Paraguay in 2002 to that in 2004?
Your answer should be compact. 0.6. What is the ratio of the Taxes (in US$) of Canada in 2002 to that in 2005?
Your answer should be compact. 0.9. What is the ratio of the Taxes (in US$) in Nigeria in 2002 to that in 2005?
Provide a succinct answer. 1.32. What is the ratio of the Taxes (in US$) in Paraguay in 2002 to that in 2005?
Give a very brief answer. 0.56. What is the ratio of the Taxes (in US$) of Canada in 2002 to that in 2006?
Keep it short and to the point. 0.88. What is the ratio of the Taxes (in US$) in Nigeria in 2002 to that in 2006?
Your response must be concise. 1.49. What is the ratio of the Taxes (in US$) in Paraguay in 2002 to that in 2006?
Your response must be concise. 0.48. What is the ratio of the Taxes (in US$) in Canada in 2002 to that in 2007?
Offer a very short reply. 0.85. What is the ratio of the Taxes (in US$) of Nigeria in 2002 to that in 2007?
Your response must be concise. 0.76. What is the ratio of the Taxes (in US$) in Paraguay in 2002 to that in 2007?
Keep it short and to the point. 0.4. What is the ratio of the Taxes (in US$) of Canada in 2002 to that in 2008?
Your response must be concise. 0.9. What is the ratio of the Taxes (in US$) in Iran in 2002 to that in 2008?
Offer a very short reply. 5.99. What is the ratio of the Taxes (in US$) of Nigeria in 2002 to that in 2008?
Provide a short and direct response. 0.58. What is the ratio of the Taxes (in US$) in Paraguay in 2002 to that in 2008?
Offer a terse response. 0.33. What is the ratio of the Taxes (in US$) of Canada in 2003 to that in 2004?
Keep it short and to the point. 0.95. What is the ratio of the Taxes (in US$) in Iran in 2003 to that in 2004?
Provide a short and direct response. 1.06. What is the ratio of the Taxes (in US$) in Nigeria in 2003 to that in 2004?
Offer a terse response. 0.97. What is the ratio of the Taxes (in US$) of Paraguay in 2003 to that in 2004?
Your answer should be compact. 0.77. What is the ratio of the Taxes (in US$) in Canada in 2003 to that in 2005?
Your answer should be compact. 0.91. What is the ratio of the Taxes (in US$) in Nigeria in 2003 to that in 2005?
Provide a short and direct response. 1.57. What is the ratio of the Taxes (in US$) in Paraguay in 2003 to that in 2005?
Your answer should be very brief. 0.72. What is the ratio of the Taxes (in US$) in Canada in 2003 to that in 2006?
Offer a terse response. 0.88. What is the ratio of the Taxes (in US$) of Nigeria in 2003 to that in 2006?
Your answer should be very brief. 1.76. What is the ratio of the Taxes (in US$) in Paraguay in 2003 to that in 2006?
Your answer should be compact. 0.63. What is the ratio of the Taxes (in US$) of Canada in 2003 to that in 2007?
Provide a short and direct response. 0.86. What is the ratio of the Taxes (in US$) of Nigeria in 2003 to that in 2007?
Offer a terse response. 0.9. What is the ratio of the Taxes (in US$) of Paraguay in 2003 to that in 2007?
Make the answer very short. 0.52. What is the ratio of the Taxes (in US$) of Canada in 2003 to that in 2008?
Offer a terse response. 0.9. What is the ratio of the Taxes (in US$) in Iran in 2003 to that in 2008?
Your response must be concise. 8.99. What is the ratio of the Taxes (in US$) in Nigeria in 2003 to that in 2008?
Offer a very short reply. 0.69. What is the ratio of the Taxes (in US$) in Paraguay in 2003 to that in 2008?
Keep it short and to the point. 0.42. What is the ratio of the Taxes (in US$) in Nigeria in 2004 to that in 2005?
Keep it short and to the point. 1.61. What is the ratio of the Taxes (in US$) of Paraguay in 2004 to that in 2005?
Provide a succinct answer. 0.93. What is the ratio of the Taxes (in US$) of Canada in 2004 to that in 2006?
Offer a terse response. 0.93. What is the ratio of the Taxes (in US$) in Nigeria in 2004 to that in 2006?
Give a very brief answer. 1.81. What is the ratio of the Taxes (in US$) of Paraguay in 2004 to that in 2006?
Offer a very short reply. 0.81. What is the ratio of the Taxes (in US$) of Canada in 2004 to that in 2007?
Make the answer very short. 0.91. What is the ratio of the Taxes (in US$) of Nigeria in 2004 to that in 2007?
Your answer should be very brief. 0.93. What is the ratio of the Taxes (in US$) of Paraguay in 2004 to that in 2007?
Offer a terse response. 0.67. What is the ratio of the Taxes (in US$) in Canada in 2004 to that in 2008?
Offer a terse response. 0.96. What is the ratio of the Taxes (in US$) of Iran in 2004 to that in 2008?
Offer a very short reply. 8.44. What is the ratio of the Taxes (in US$) of Nigeria in 2004 to that in 2008?
Offer a very short reply. 0.71. What is the ratio of the Taxes (in US$) in Paraguay in 2004 to that in 2008?
Offer a very short reply. 0.55. What is the ratio of the Taxes (in US$) of Canada in 2005 to that in 2006?
Offer a terse response. 0.97. What is the ratio of the Taxes (in US$) of Nigeria in 2005 to that in 2006?
Your response must be concise. 1.12. What is the ratio of the Taxes (in US$) in Paraguay in 2005 to that in 2006?
Offer a very short reply. 0.87. What is the ratio of the Taxes (in US$) in Canada in 2005 to that in 2007?
Provide a short and direct response. 0.95. What is the ratio of the Taxes (in US$) of Nigeria in 2005 to that in 2007?
Make the answer very short. 0.58. What is the ratio of the Taxes (in US$) in Paraguay in 2005 to that in 2007?
Ensure brevity in your answer.  0.72. What is the ratio of the Taxes (in US$) in Nigeria in 2005 to that in 2008?
Give a very brief answer. 0.44. What is the ratio of the Taxes (in US$) in Paraguay in 2005 to that in 2008?
Keep it short and to the point. 0.59. What is the ratio of the Taxes (in US$) of Canada in 2006 to that in 2007?
Provide a short and direct response. 0.97. What is the ratio of the Taxes (in US$) of Nigeria in 2006 to that in 2007?
Offer a terse response. 0.51. What is the ratio of the Taxes (in US$) of Paraguay in 2006 to that in 2007?
Offer a very short reply. 0.83. What is the ratio of the Taxes (in US$) in Canada in 2006 to that in 2008?
Your answer should be very brief. 1.02. What is the ratio of the Taxes (in US$) in Nigeria in 2006 to that in 2008?
Offer a very short reply. 0.39. What is the ratio of the Taxes (in US$) of Paraguay in 2006 to that in 2008?
Give a very brief answer. 0.68. What is the ratio of the Taxes (in US$) of Canada in 2007 to that in 2008?
Offer a very short reply. 1.05. What is the ratio of the Taxes (in US$) of Nigeria in 2007 to that in 2008?
Your answer should be very brief. 0.77. What is the ratio of the Taxes (in US$) in Paraguay in 2007 to that in 2008?
Ensure brevity in your answer.  0.82. What is the difference between the highest and the second highest Taxes (in US$) of Canada?
Provide a short and direct response. 2.65e+09. What is the difference between the highest and the second highest Taxes (in US$) of Iran?
Offer a very short reply. 8.60e+11. What is the difference between the highest and the second highest Taxes (in US$) of Nigeria?
Offer a very short reply. 8.53e+1. What is the difference between the highest and the second highest Taxes (in US$) of Paraguay?
Make the answer very short. 1.25e+12. What is the difference between the highest and the lowest Taxes (in US$) of Canada?
Your answer should be very brief. 2.30e+1. What is the difference between the highest and the lowest Taxes (in US$) in Iran?
Your response must be concise. 1.42e+13. What is the difference between the highest and the lowest Taxes (in US$) of Nigeria?
Make the answer very short. 2.24e+11. What is the difference between the highest and the lowest Taxes (in US$) of Paraguay?
Your response must be concise. 4.67e+12. 